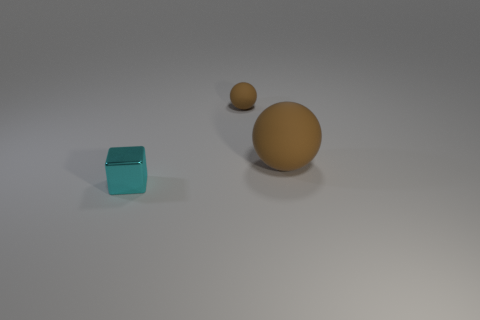Add 3 brown matte things. How many objects exist? 6 Subtract all cubes. How many objects are left? 2 Subtract all big blue rubber blocks. Subtract all large matte things. How many objects are left? 2 Add 2 brown balls. How many brown balls are left? 4 Add 3 large things. How many large things exist? 4 Subtract 0 purple cylinders. How many objects are left? 3 